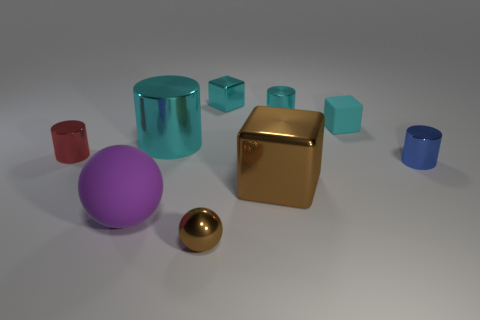Subtract all tiny blocks. How many blocks are left? 1 Subtract all purple balls. How many cyan blocks are left? 2 Subtract 1 cylinders. How many cylinders are left? 3 Subtract all red cylinders. How many cylinders are left? 3 Subtract all yellow cubes. Subtract all blue balls. How many cubes are left? 3 Add 4 small brown spheres. How many small brown spheres exist? 5 Subtract 0 purple blocks. How many objects are left? 9 Subtract all blocks. How many objects are left? 6 Subtract all green metallic spheres. Subtract all rubber spheres. How many objects are left? 8 Add 7 small cyan metal blocks. How many small cyan metal blocks are left? 8 